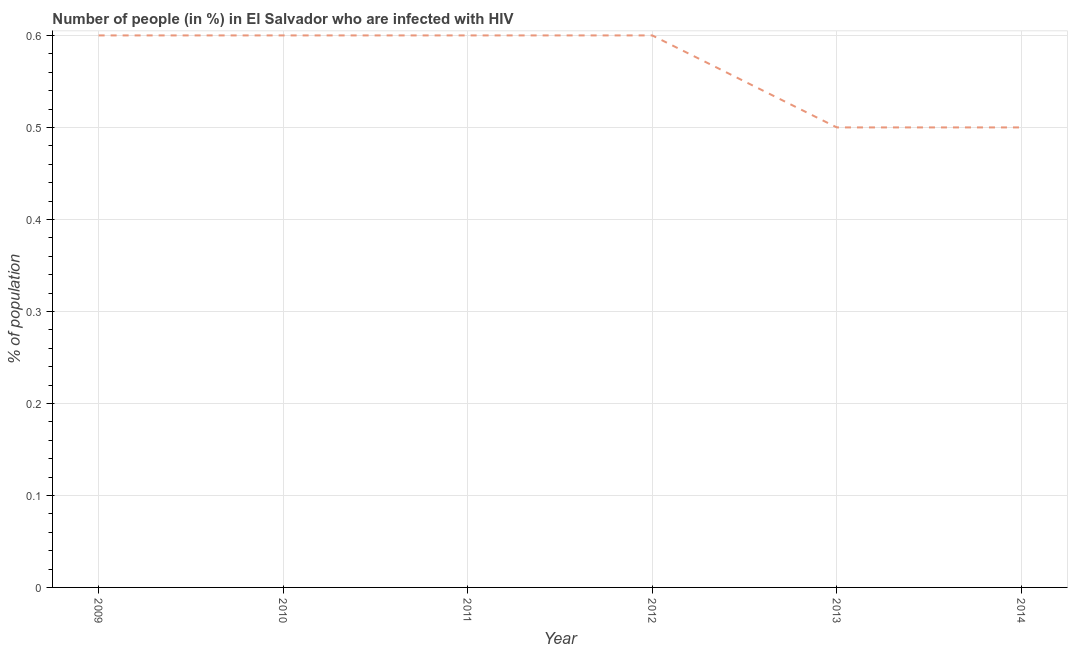Across all years, what is the maximum number of people infected with hiv?
Offer a very short reply. 0.6. Across all years, what is the minimum number of people infected with hiv?
Your answer should be compact. 0.5. In which year was the number of people infected with hiv maximum?
Ensure brevity in your answer.  2009. In which year was the number of people infected with hiv minimum?
Your response must be concise. 2013. What is the difference between the number of people infected with hiv in 2011 and 2013?
Your answer should be compact. 0.1. What is the average number of people infected with hiv per year?
Offer a terse response. 0.57. In how many years, is the number of people infected with hiv greater than 0.02 %?
Keep it short and to the point. 6. Is the difference between the number of people infected with hiv in 2011 and 2014 greater than the difference between any two years?
Offer a very short reply. Yes. What is the difference between the highest and the second highest number of people infected with hiv?
Provide a succinct answer. 0. What is the difference between the highest and the lowest number of people infected with hiv?
Offer a very short reply. 0.1. In how many years, is the number of people infected with hiv greater than the average number of people infected with hiv taken over all years?
Your answer should be very brief. 4. How many years are there in the graph?
Your answer should be compact. 6. What is the difference between two consecutive major ticks on the Y-axis?
Give a very brief answer. 0.1. Does the graph contain any zero values?
Your response must be concise. No. Does the graph contain grids?
Ensure brevity in your answer.  Yes. What is the title of the graph?
Your response must be concise. Number of people (in %) in El Salvador who are infected with HIV. What is the label or title of the Y-axis?
Ensure brevity in your answer.  % of population. What is the % of population of 2010?
Your answer should be compact. 0.6. What is the % of population in 2014?
Ensure brevity in your answer.  0.5. What is the difference between the % of population in 2009 and 2010?
Offer a very short reply. 0. What is the difference between the % of population in 2009 and 2012?
Give a very brief answer. 0. What is the difference between the % of population in 2009 and 2013?
Offer a terse response. 0.1. What is the difference between the % of population in 2009 and 2014?
Provide a short and direct response. 0.1. What is the difference between the % of population in 2010 and 2011?
Make the answer very short. 0. What is the difference between the % of population in 2010 and 2013?
Provide a short and direct response. 0.1. What is the difference between the % of population in 2011 and 2012?
Make the answer very short. 0. What is the difference between the % of population in 2011 and 2014?
Make the answer very short. 0.1. What is the difference between the % of population in 2012 and 2013?
Ensure brevity in your answer.  0.1. What is the ratio of the % of population in 2009 to that in 2010?
Offer a terse response. 1. What is the ratio of the % of population in 2009 to that in 2011?
Give a very brief answer. 1. What is the ratio of the % of population in 2009 to that in 2014?
Offer a very short reply. 1.2. What is the ratio of the % of population in 2010 to that in 2014?
Make the answer very short. 1.2. What is the ratio of the % of population in 2011 to that in 2012?
Provide a succinct answer. 1. What is the ratio of the % of population in 2011 to that in 2013?
Make the answer very short. 1.2. What is the ratio of the % of population in 2012 to that in 2013?
Offer a terse response. 1.2. What is the ratio of the % of population in 2012 to that in 2014?
Ensure brevity in your answer.  1.2. 